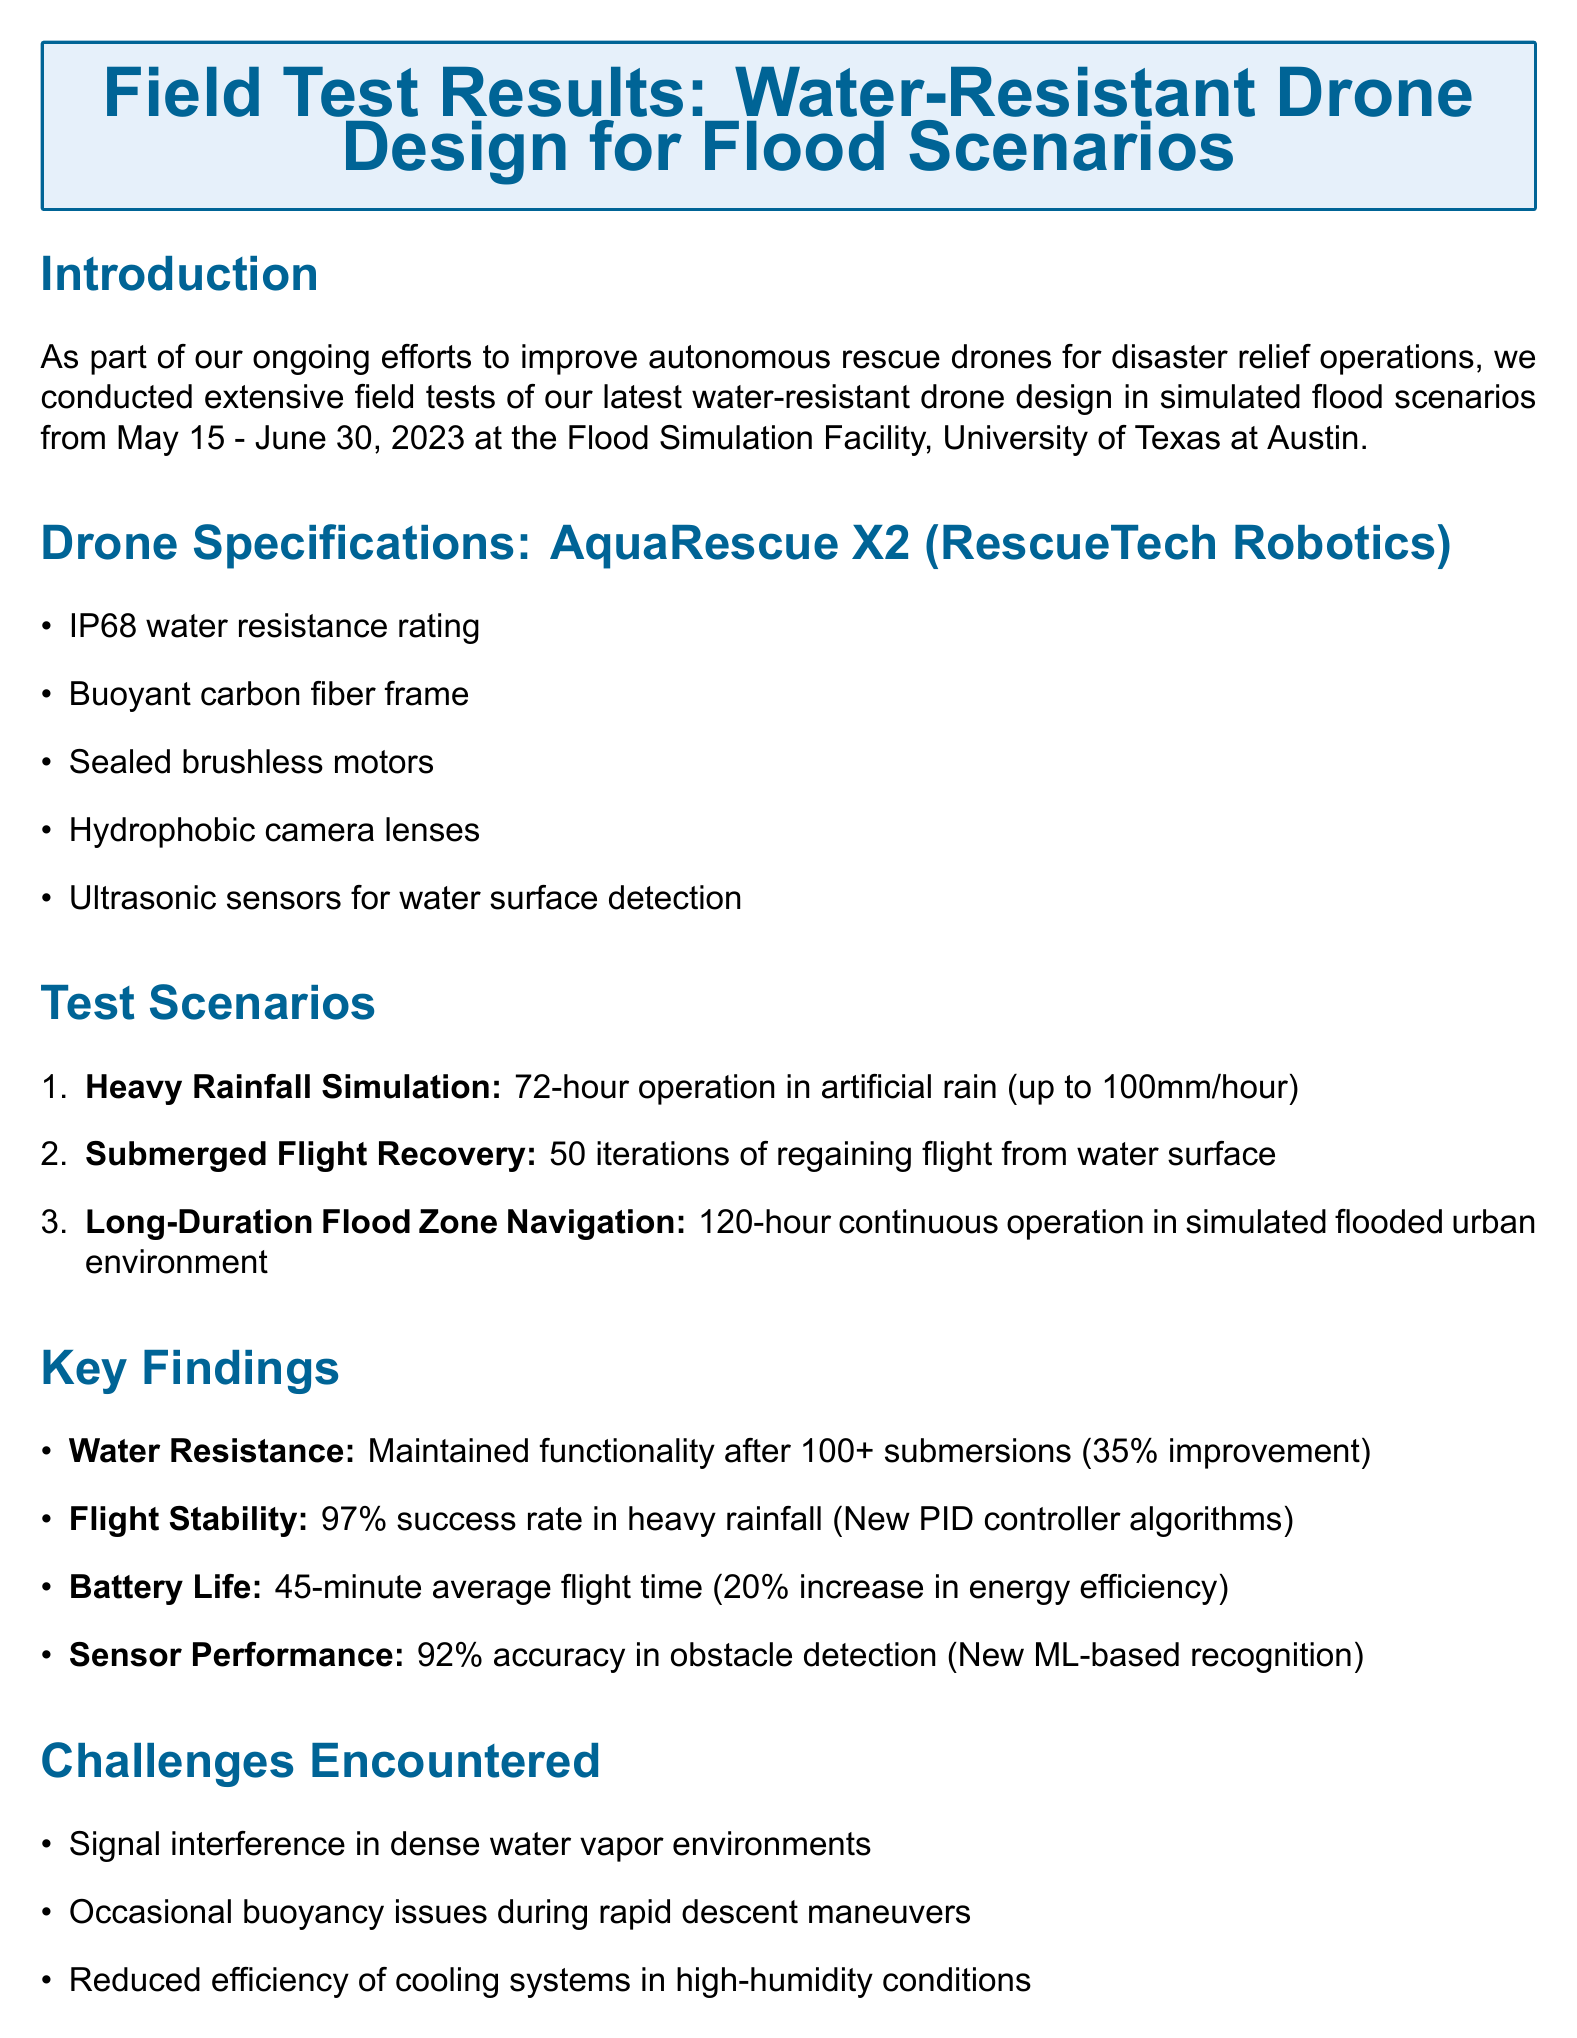What was the test period for the field tests? The test period is mentioned in the introduction as May 15 - June 30, 2023.
Answer: May 15 - June 30, 2023 What is the IP rating for the AquaRescue X2? The drone specifications indicate that the AquaRescue X2 has an IP68 water resistance rating.
Answer: IP68 How many iterations were conducted for submerged flight recovery? In the test scenarios, it is stated that there were 50 iterations for submerged flight recovery.
Answer: 50 What was the success rate in maintaining stable flight during heavy rainfall? The key findings reveal a 97% success rate for flight stability during heavy rainfall.
Answer: 97% What improvement was noted in water resistance compared to the previous model? The document states that there is a 35% increase in water resistance compared to the previous model.
Answer: 35% What challenge was encountered related to cooling systems? One of the challenges mentioned is the reduced efficiency of cooling systems in high-humidity conditions.
Answer: Reduced efficiency of cooling systems What collaboration is planned for real-world scenarios? The next steps mention collaborating with NOAA for tests in real-world flood scenarios.
Answer: NOAA What percentage increase in battery life was achieved during tests? The key findings indicate a 20% increase in energy efficiency for average battery life.
Answer: 20% 